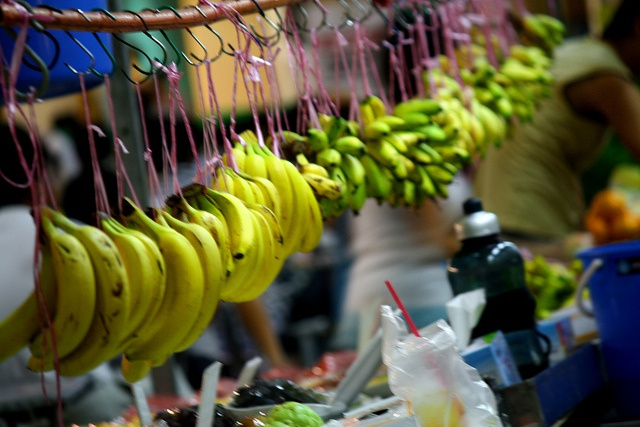Describe the objects in this image and their specific colors. I can see banana in navy, olive, black, and khaki tones, people in navy, black, and olive tones, bottle in navy, black, gray, darkgray, and white tones, banana in navy, olive, black, and khaki tones, and banana in navy, olive, and yellow tones in this image. 